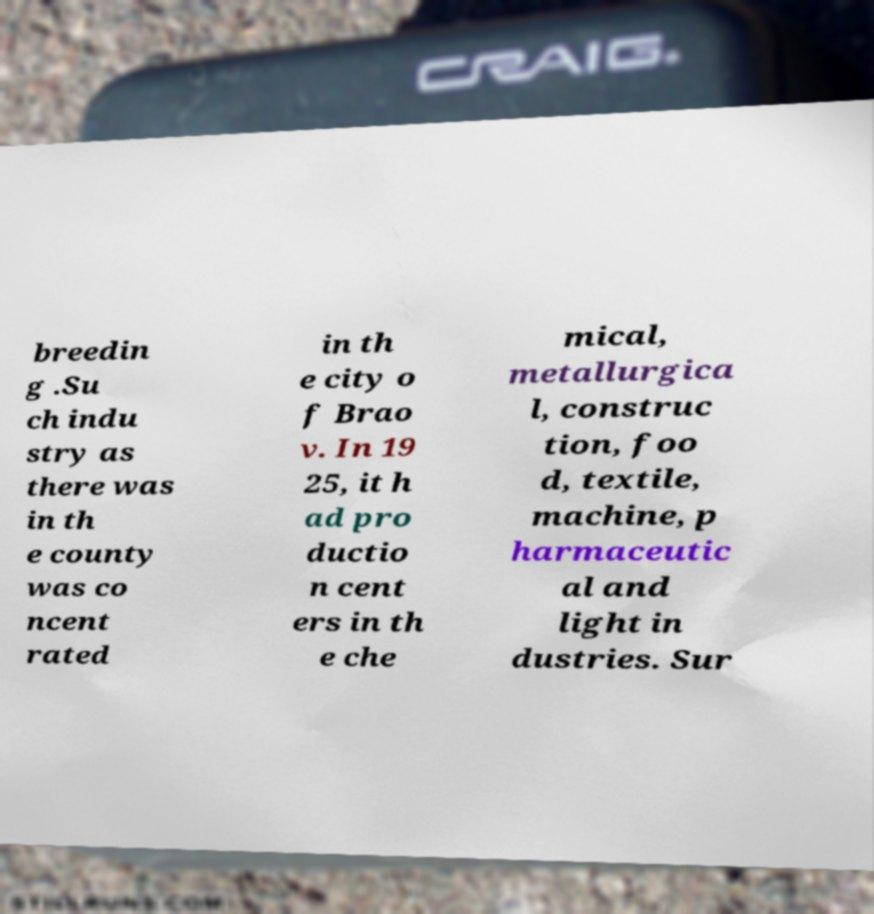What messages or text are displayed in this image? I need them in a readable, typed format. breedin g .Su ch indu stry as there was in th e county was co ncent rated in th e city o f Brao v. In 19 25, it h ad pro ductio n cent ers in th e che mical, metallurgica l, construc tion, foo d, textile, machine, p harmaceutic al and light in dustries. Sur 